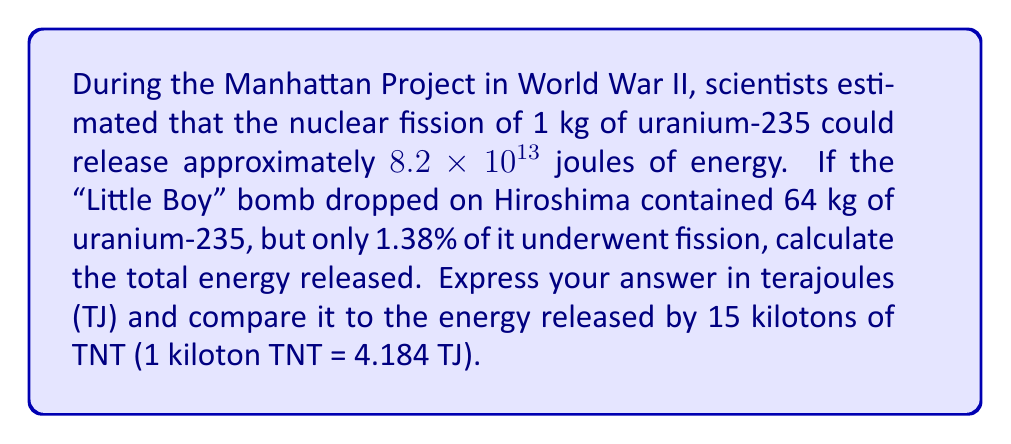Show me your answer to this math problem. Let's approach this step-by-step:

1) First, we need to calculate the mass of uranium-235 that actually underwent fission:
   $64 \text{ kg} \times 1.38\% = 64 \text{ kg} \times 0.0138 = 0.8832 \text{ kg}$

2) Now, we can calculate the energy released by this amount of uranium-235:
   $E = 0.8832 \text{ kg} \times 8.2 \times 10^{13} \text{ J/kg} = 7.24224 \times 10^{13} \text{ J}$

3) Convert joules to terajoules:
   $7.24224 \times 10^{13} \text{ J} \times \frac{1 \text{ TJ}}{10^{12} \text{ J}} = 72.4224 \text{ TJ}$

4) Calculate the energy equivalent of 15 kilotons of TNT:
   $15 \times 4.184 \text{ TJ} = 62.76 \text{ TJ}$

5) Compare the two values:
   $\frac{72.4224 \text{ TJ}}{62.76 \text{ TJ}} \approx 1.154$

Therefore, the energy released by the Little Boy bomb was about 1.154 times the energy of 15 kilotons of TNT.
Answer: 72.4224 TJ, approximately 1.154 times the energy of 15 kilotons of TNT 